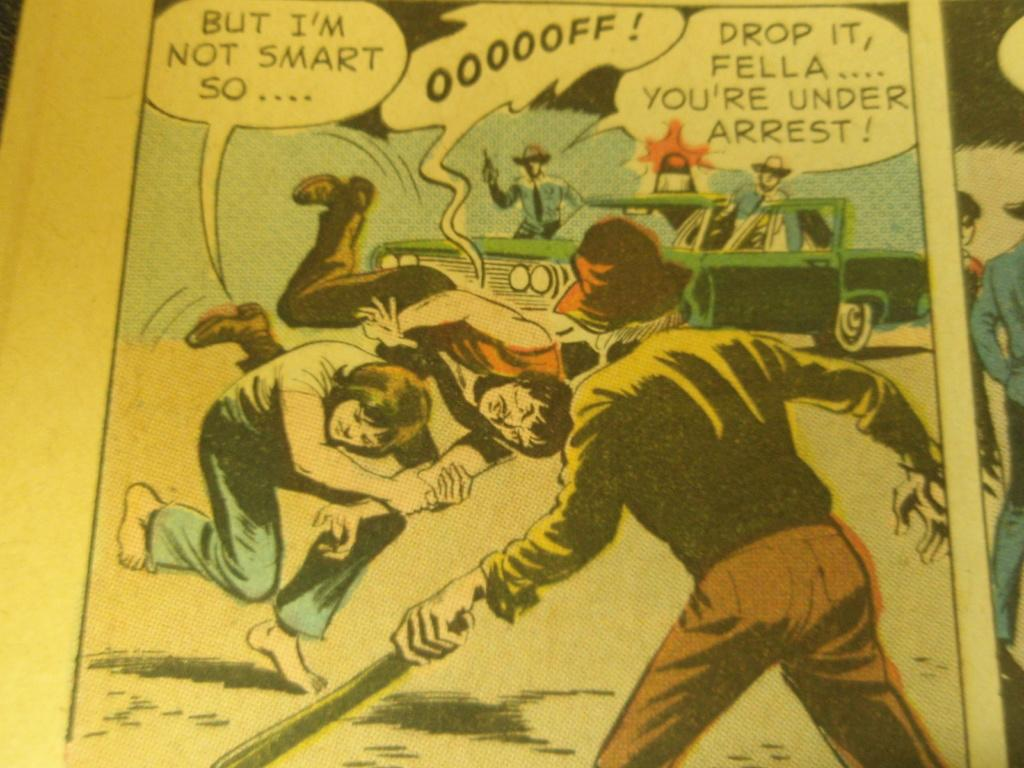<image>
Offer a succinct explanation of the picture presented. A comic book page with the first bubble quote saying, " But I'm not smart so....". 